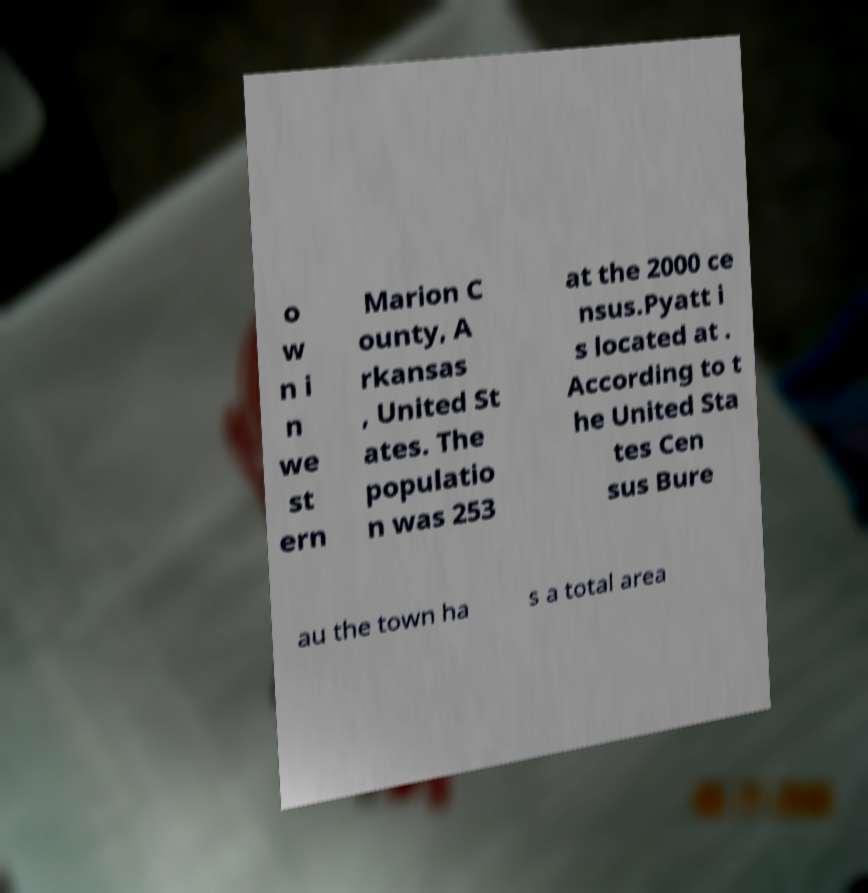Can you accurately transcribe the text from the provided image for me? o w n i n we st ern Marion C ounty, A rkansas , United St ates. The populatio n was 253 at the 2000 ce nsus.Pyatt i s located at . According to t he United Sta tes Cen sus Bure au the town ha s a total area 